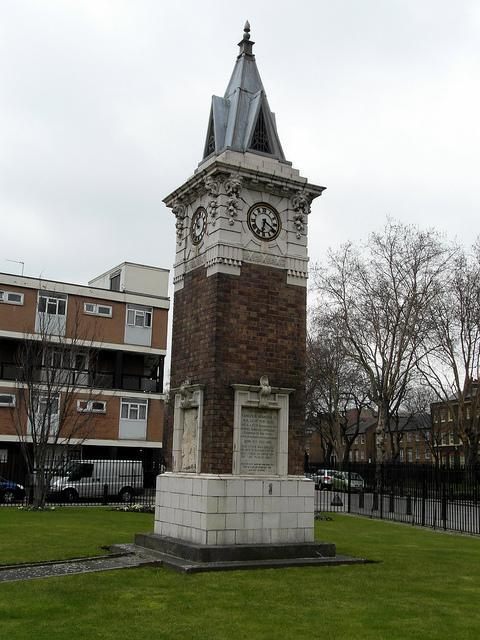What color are the square bricks outlining the base of this small clock tower?

Choices:
A) red
B) tan
C) black
D) white white 